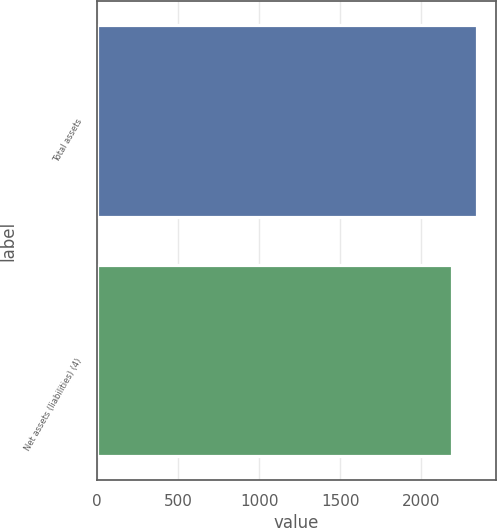Convert chart to OTSL. <chart><loc_0><loc_0><loc_500><loc_500><bar_chart><fcel>Total assets<fcel>Net assets (liabilities) (4)<nl><fcel>2342<fcel>2191<nl></chart> 